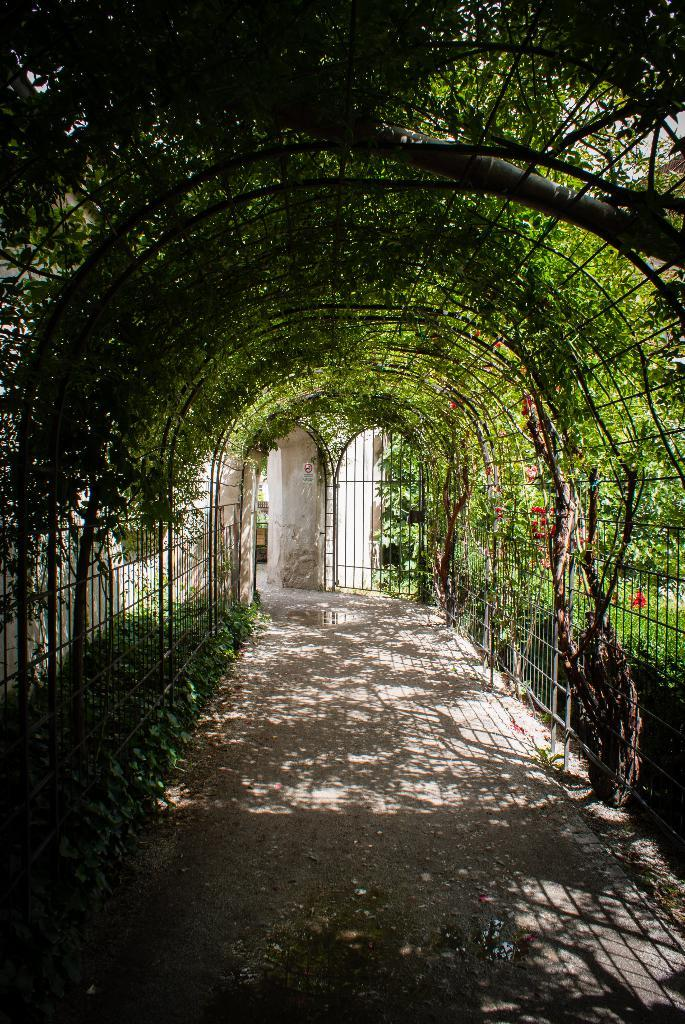What type of path is present in the image? There is a walkway in the image. What can be seen at the top of the image? Trees are visible at the top of the image. Where are plants located in the image? There are plants on both the right and left sides of the image. What architectural feature is present in the background of the image? There is a wall in the center of the background of the image. What type of cannon is used to answer questions in the image? There is no cannon present in the image, and cannons are not used to answer questions. 